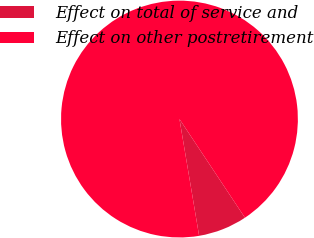Convert chart. <chart><loc_0><loc_0><loc_500><loc_500><pie_chart><fcel>Effect on total of service and<fcel>Effect on other postretirement<nl><fcel>6.67%<fcel>93.33%<nl></chart> 